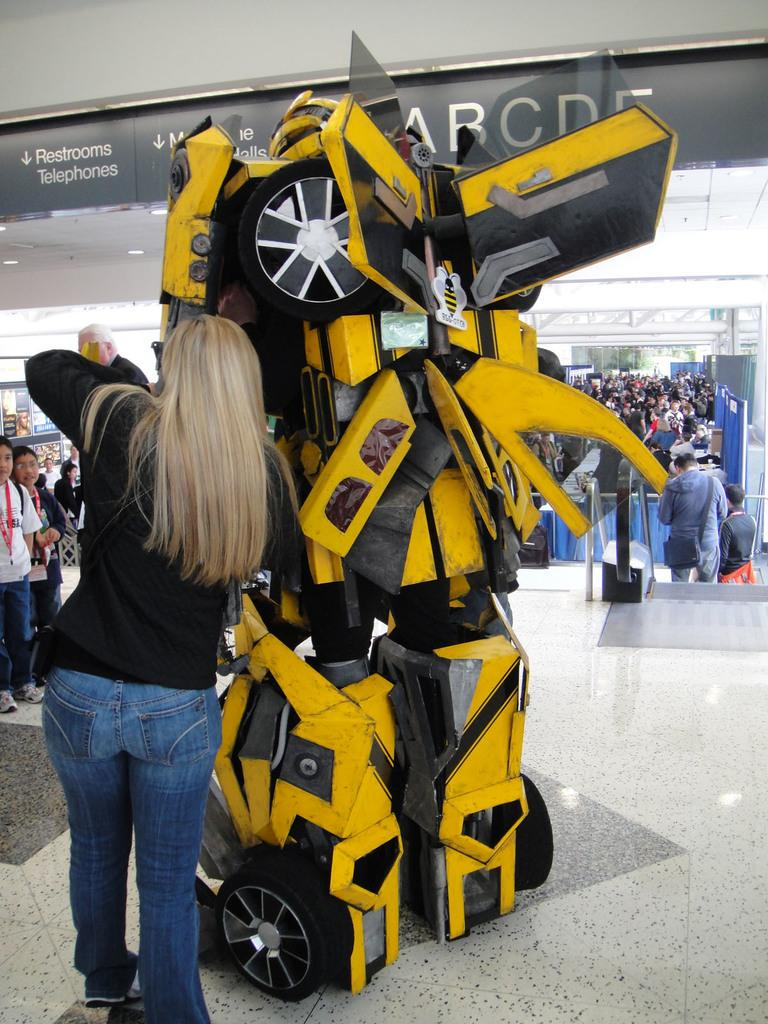What is located in the foreground of the image? There is a person standing and a robotic car in the foreground of the image. How many people are visible in the image? There is one person in the foreground and many people in the background of the image. What color are the eyes of the robotic car in the image? The robotic car does not have eyes, as it is a car and not a living being. 